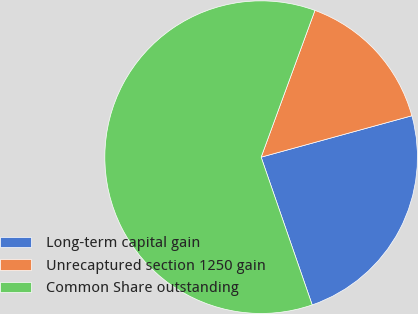Convert chart. <chart><loc_0><loc_0><loc_500><loc_500><pie_chart><fcel>Long-term capital gain<fcel>Unrecaptured section 1250 gain<fcel>Common Share outstanding<nl><fcel>23.97%<fcel>15.14%<fcel>60.88%<nl></chart> 